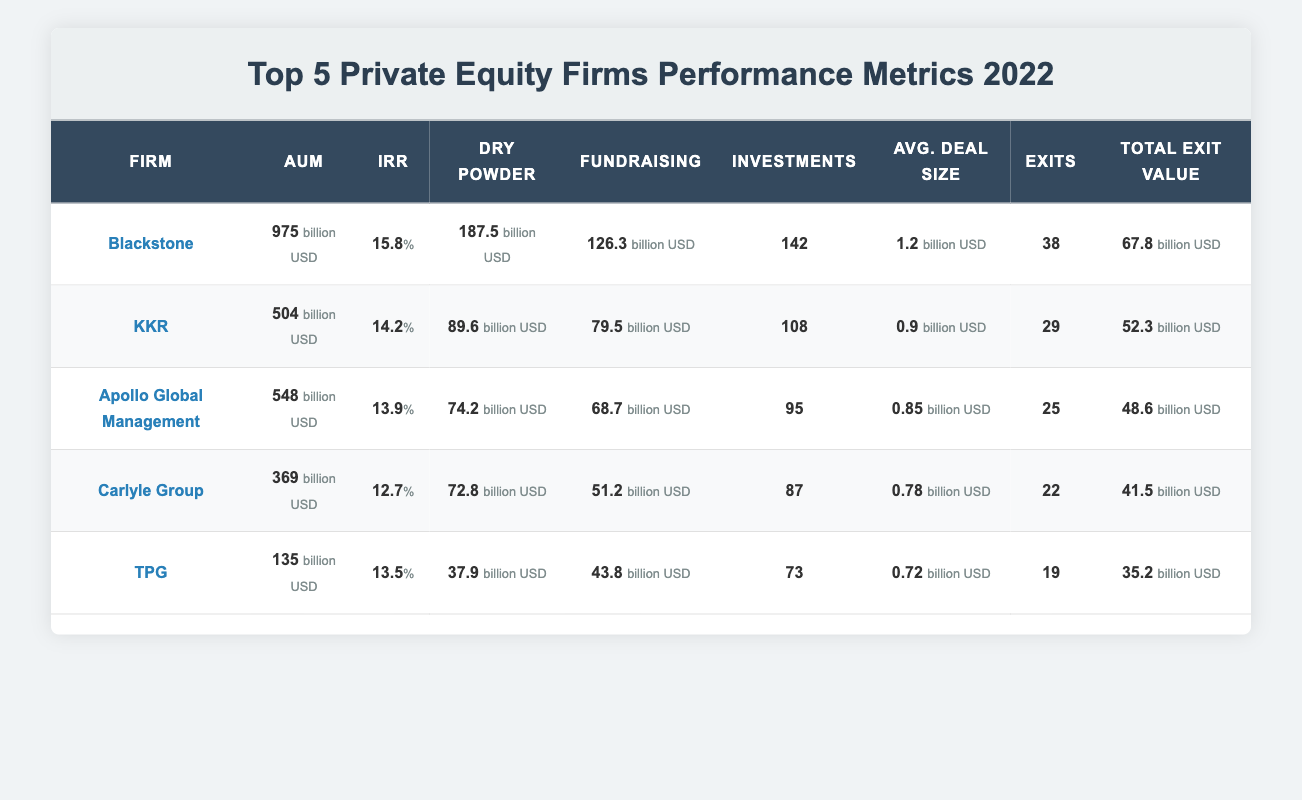What is the AUM of Apollo Global Management? The table lists the AUM for Apollo Global Management as 548 billion USD in the corresponding row.
Answer: 548 billion USD Which firm has the highest IRR? The IRR values for each firm are compared: Blackstone has 15.8 percent, KKR has 14.2 percent, Apollo has 13.9 percent, Carlyle has 12.7 percent, and TPG has 13.5 percent. Hence, Blackstone has the highest IRR.
Answer: Blackstone What is the total dry powder across all firms? To find the total dry powder, add the dry powder amounts for all firms: 187.5 + 89.6 + 74.2 + 72.8 + 37.9 = 462.0 billion USD.
Answer: 462.0 billion USD Does Carlyle Group have more exits than TPG? Carlyle Group has 22 exits while TPG has 19 exits. Since 22 is greater than 19, the statement is true.
Answer: Yes What is the average deal size of all firms? To find the average deal size, sum up the average deal sizes: 1.2 + 0.9 + 0.85 + 0.78 + 0.72 = 4.65 billion USD. Then, divide by the number of firms (5): 4.65 / 5 = 0.93 billion USD.
Answer: 0.93 billion USD What is the difference in total exit value between Blackstone and Carlyle Group? The total exit value for Blackstone is 67.8 billion USD and for Carlyle Group, it is 41.5 billion USD. Calculating the difference: 67.8 - 41.5 = 26.3 billion USD.
Answer: 26.3 billion USD Which firm raised the most money in fundraising? The fundraising amounts are as follows: Blackstone 126.3 billion USD, KKR 79.5 billion USD, Apollo 68.7 billion USD, Carlyle 51.2 billion USD, and TPG 43.8 billion USD. The highest amount is from Blackstone.
Answer: Blackstone Is the number of investments for Apollo Global Management greater than KKR? Apollo Global Management has 95 investments while KKR has 108 investments. Since 95 is less than 108, the statement is false.
Answer: No What percentage of total investments does Blackstone contribute from the total investments across all firms? The total number of investments across all firms is 142 + 108 + 95 + 87 + 73 = 505. The percentage for Blackstone is (142 / 505) * 100 ≈ 28.1 percent.
Answer: 28.1 percent 